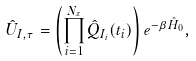<formula> <loc_0><loc_0><loc_500><loc_500>\hat { U } _ { I , \tau } = \left ( \prod _ { i = 1 } ^ { N _ { x } } \hat { Q } _ { I _ { i } } ( t _ { i } ) \right ) e ^ { - \beta \hat { H } _ { 0 } } ,</formula> 